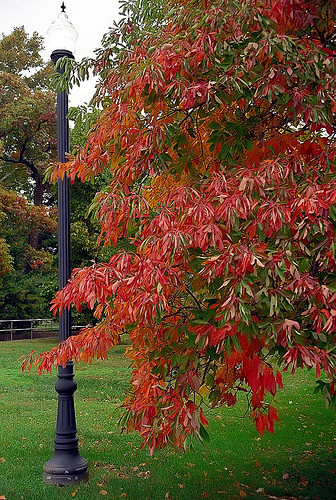<image>
Can you confirm if the tree is in front of the light pole? Yes. The tree is positioned in front of the light pole, appearing closer to the camera viewpoint. Is there a lamp post in front of the tree branch? No. The lamp post is not in front of the tree branch. The spatial positioning shows a different relationship between these objects. 